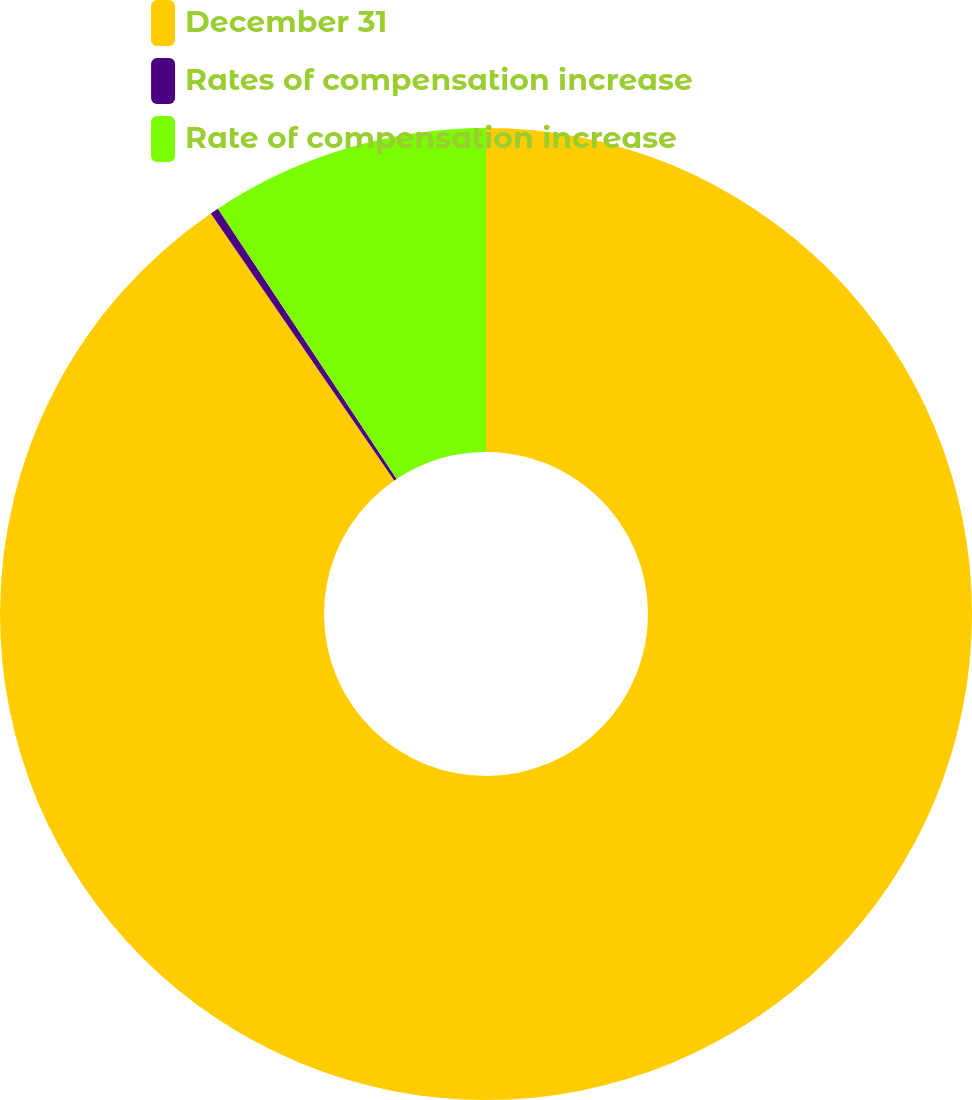<chart> <loc_0><loc_0><loc_500><loc_500><pie_chart><fcel>December 31<fcel>Rates of compensation increase<fcel>Rate of compensation increase<nl><fcel>90.42%<fcel>0.28%<fcel>9.3%<nl></chart> 